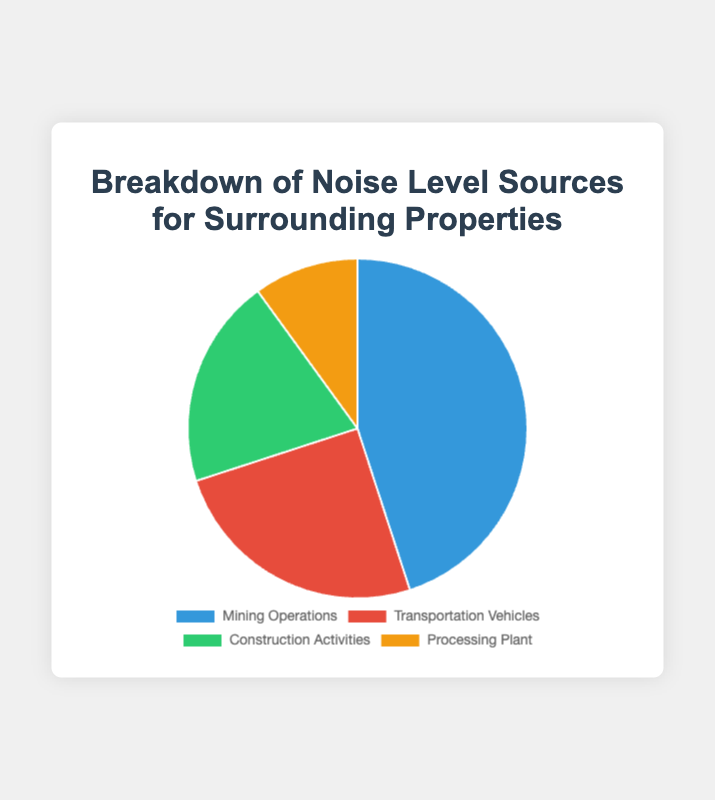What percentage of noise is produced by the Transportation Vehicles? The figure shows that Transportation Vehicles account for 25% of the total noise level sources.
Answer: 25% Which noise source contributes the most to the noise levels around the properties? The figure clearly indicates that Mining Operations have the largest share of noise contribution at 45%.
Answer: Mining Operations How much more noise is generated by Mining Operations compared to the Processing Plant? Mining Operations contribute 45% and the Processing Plant contributes 10%. The difference is 45% - 10% = 35%.
Answer: 35% What is the combined percentage of noise contributions from Construction Activities and the Processing Plant? Construction Activities contribute 20% and the Processing Plant contributes 10%. Combined, they contribute 20% + 10% = 30%.
Answer: 30% Out of the four sources, which two contribute equally to the noise levels? None of the sources shown in the figure have the same percentage, thus there are no pairs contributing equally.
Answer: None What color represents the noise percentage contributed by the Processing Plant? The Processing Plant segment is visually represented by the color orange in the chart.
Answer: Orange Is there any source of noise that contributes less than 15%? The Processing Plant is the only source that contributes less than 15% to the noise levels, specifically 10%.
Answer: Yes Rank the noise sources from highest to lowest contribution. The noise sources, from highest to lowest contribution, are: Mining Operations (45%), Transportation Vehicles (25%), Construction Activities (20%), Processing Plant (10%).
Answer: Mining Operations > Transportation Vehicles > Construction Activities > Processing Plant Is the combined noise contribution from Transportation Vehicles and Construction Activities greater than the contribution from Mining Operations? The combined percentage of noise from Transportation Vehicles (25%) and Construction Activities (20%) is 25% + 20% = 45%, which is equal to the contribution from Mining Operations.
Answer: Equal What is the average percentage of noise contributed by all sources? The total percentage is 45% + 25% + 20% + 10% = 100%. There are 4 sources, so the average is 100% / 4 = 25%.
Answer: 25% 